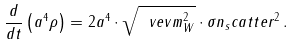Convert formula to latex. <formula><loc_0><loc_0><loc_500><loc_500>\frac { d } { d t } \left ( a ^ { 4 } \rho \right ) = 2 a ^ { 4 } \cdot \sqrt { \ v e v { m _ { W } ^ { 2 } } } \cdot \sigma n _ { s } c a t t e r ^ { 2 } \, .</formula> 